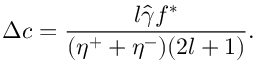Convert formula to latex. <formula><loc_0><loc_0><loc_500><loc_500>\Delta c = \frac { l \hat { \gamma } f ^ { * } } { ( \eta ^ { + } + \eta ^ { - } ) ( 2 l + 1 ) } .</formula> 